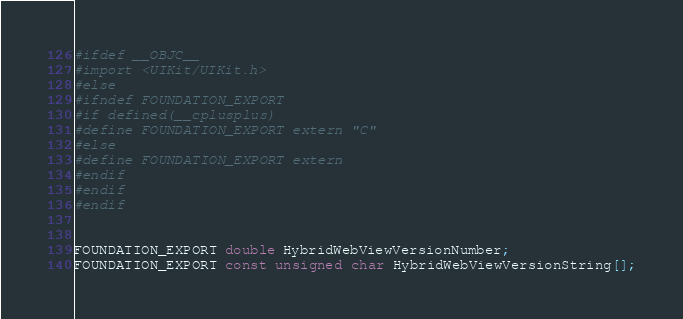<code> <loc_0><loc_0><loc_500><loc_500><_C_>#ifdef __OBJC__
#import <UIKit/UIKit.h>
#else
#ifndef FOUNDATION_EXPORT
#if defined(__cplusplus)
#define FOUNDATION_EXPORT extern "C"
#else
#define FOUNDATION_EXPORT extern
#endif
#endif
#endif


FOUNDATION_EXPORT double HybridWebViewVersionNumber;
FOUNDATION_EXPORT const unsigned char HybridWebViewVersionString[];

</code> 